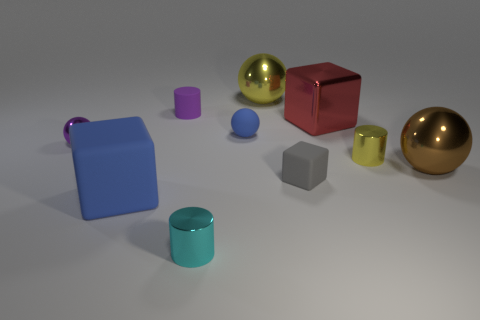Subtract all blue spheres. How many spheres are left? 3 Subtract 1 blocks. How many blocks are left? 2 Subtract all blue cubes. How many cubes are left? 2 Subtract all cylinders. How many objects are left? 7 Subtract 1 cyan cylinders. How many objects are left? 9 Subtract all green blocks. Subtract all blue balls. How many blocks are left? 3 Subtract all red spheres. How many purple cylinders are left? 1 Subtract all purple metallic spheres. Subtract all large brown metal objects. How many objects are left? 8 Add 3 small blue matte things. How many small blue matte things are left? 4 Add 9 brown balls. How many brown balls exist? 10 